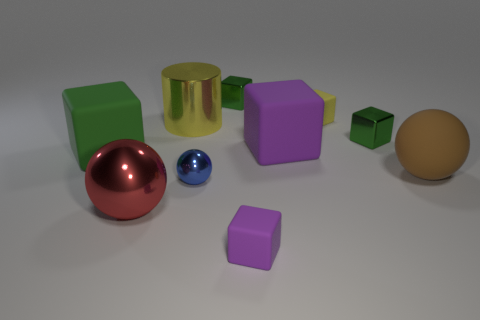How many other objects are the same material as the cylinder? Including the gold cylinder in the image, there are five objects that appear to have a metallic finish, suggesting they might be of similar materials. These include the small and large silver spheres, and the two smaller cubes, one green and one purple, all of which have reflective surfaces characteristic of metals. 